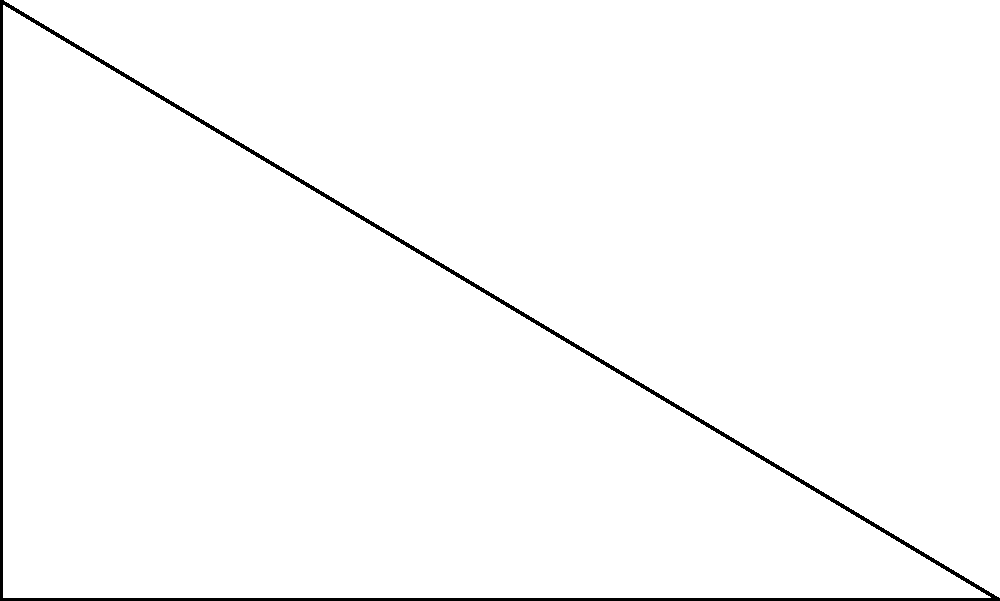During a corner kick practice, you're positioned at point A on the football pitch. The corner flag is at point C, 3 meters away from you. The goal post is at point B, 5 meters from where you're standing. What is the angle $\theta$ (in degrees) at which you need to kick the ball to reach the corner flag? To find the angle $\theta$, we can use the trigonometric function tangent in the right-angled triangle ABC:

1) In a right-angled triangle, $\tan \theta = \frac{\text{opposite}}{\text{adjacent}}$

2) Here, the opposite side is AC (3m) and the adjacent side is AB (5m)

3) Therefore, $\tan \theta = \frac{3}{5}$

4) To find $\theta$, we need to use the inverse tangent function (arctan or $\tan^{-1}$):

   $\theta = \tan^{-1}(\frac{3}{5})$

5) Using a calculator or trigonometric tables:

   $\theta \approx 30.96^\circ$

6) Rounding to the nearest degree:

   $\theta \approx 31^\circ$
Answer: $31^\circ$ 